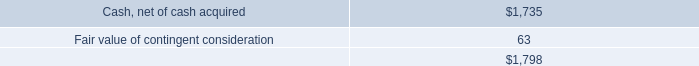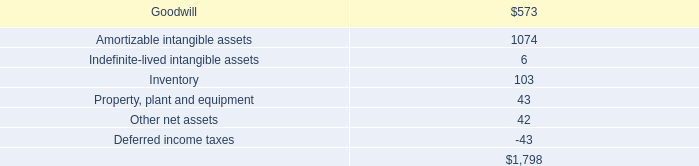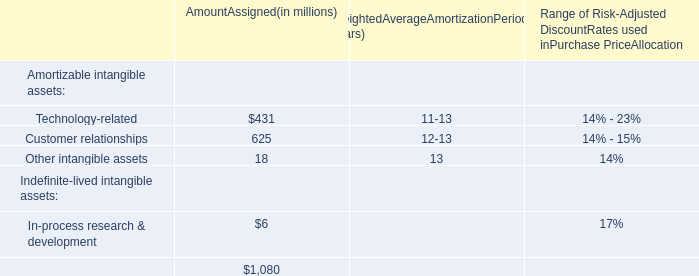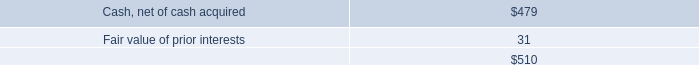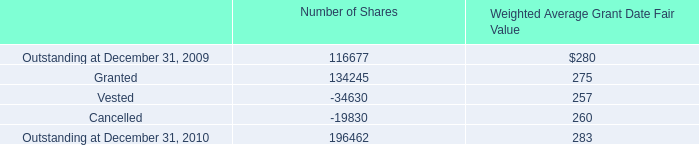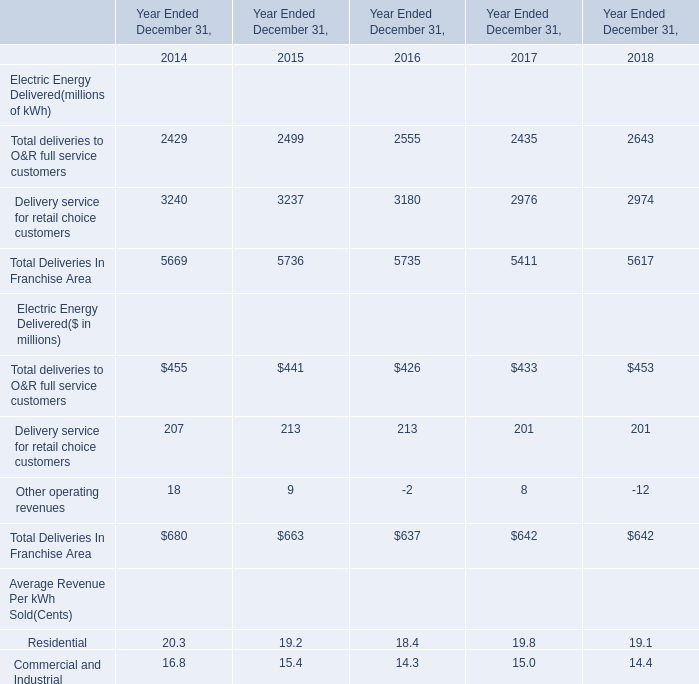In the year with largest amount of deliveries to O&R full service customers (millions of kWh), what's the increasing rate of Total Deliveries In Franchise Area? 
Computations: ((5735 - 5736) / 5736)
Answer: -0.00017. 